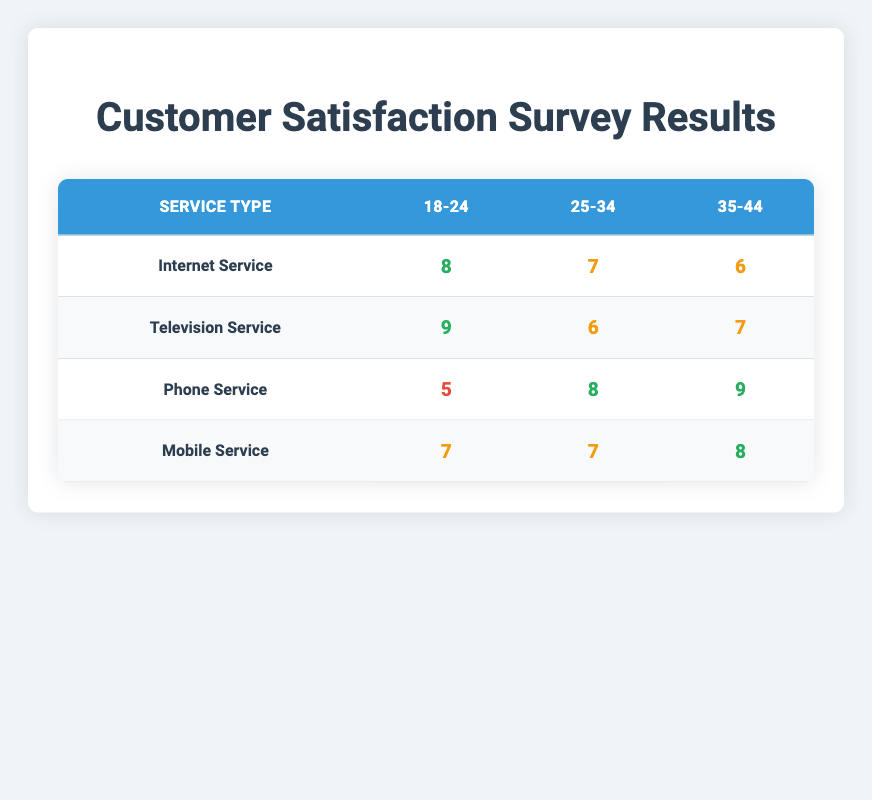What is the satisfaction score for the Television Service among the 18-24 demographic? In the table, the row for "Television Service" shows the satisfaction score for the 18-24 demographic is 9.
Answer: 9 Which service type received the lowest satisfaction score from the 18-24 demographic? By looking at the scores for the 18-24 demographic across the service types, "Phone Service" has the lowest score of 5.
Answer: Phone Service What is the average satisfaction score for the 25-34 demographic across all service types? The scores for the 25-34 demographic are 7 (Internet Service), 6 (Television Service), 8 (Phone Service), and 7 (Mobile Service). The sum is 7 + 6 + 8 + 7 = 28, and there are 4 service types, so the average is 28 / 4 = 7.
Answer: 7 Did any service type receive a satisfaction score of 10? Looking at the table, there are no scores of 10 for any service type, the highest is 9.
Answer: No Which demographic has the highest satisfaction score for Mobile Service? In the Mobile Service row, the scores are 7 for 18-24, 7 for 25-34, and 8 for 35-44. The highest score is 8 for the 35-44 demographic.
Answer: 35-44 How does the satisfaction score for Internet Service compare to that for Phone Service among the 35-44 demographic? The score for Internet Service in the 35-44 demographic is 6, while for Phone Service it is 9. Comparing the two, Phone Service has a score that is 3 points higher than Internet Service.
Answer: Phone Service is higher by 3 points What is the difference in satisfaction scores between the 25-34 and 35-44 demographics for Television Service? The scores for Television Service are 6 for 25-34 and 7 for 35-44. The difference is 7 - 6 = 1.
Answer: 1 Which service type has the highest overall satisfaction score across all demographics combined? The total scores for each service type are: Internet Service (8 + 7 + 6 = 21), Television Service (9 + 6 + 7 = 22), Phone Service (5 + 8 + 9 = 22), Mobile Service (7 + 7 + 8 = 22). Television Service has the highest score of 22.
Answer: Television Service 